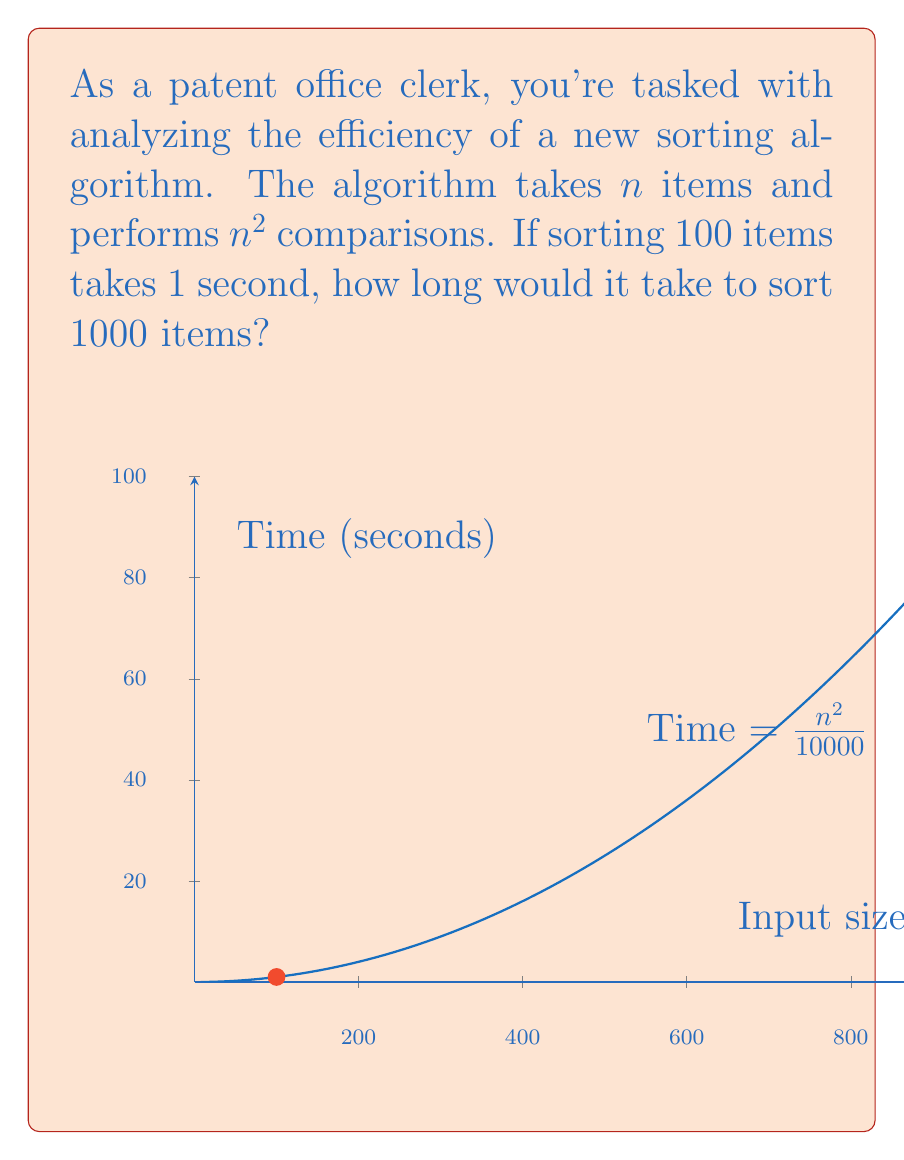Can you solve this math problem? Let's approach this step-by-step:

1) The algorithm's time complexity is $O(n^2)$, where $n$ is the input size.

2) We're given that for $n = 100$, the time taken is 1 second. Let's call the time function $T(n)$.

   $T(100) = 1$ second

3) We can express this as:

   $k \cdot 100^2 = 1$, where $k$ is some constant

4) Solving for $k$:

   $k = \frac{1}{10000} = 0.0001$

5) So our time function is:

   $T(n) = 0.0001 \cdot n^2$

6) Now, for $n = 1000$:

   $T(1000) = 0.0001 \cdot 1000^2$
            $= 0.0001 \cdot 1,000,000$
            $= 100$ seconds

7) We can verify this using the ratio of the squares:

   $\frac{1000^2}{100^2} = \frac{1,000,000}{10,000} = 100$

   So the time for 1000 items should be 100 times the time for 100 items.
Answer: 100 seconds 